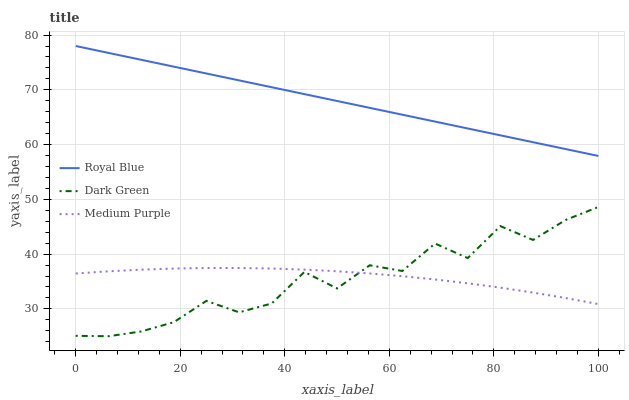Does Dark Green have the minimum area under the curve?
Answer yes or no. Yes. Does Royal Blue have the maximum area under the curve?
Answer yes or no. Yes. Does Royal Blue have the minimum area under the curve?
Answer yes or no. No. Does Dark Green have the maximum area under the curve?
Answer yes or no. No. Is Royal Blue the smoothest?
Answer yes or no. Yes. Is Dark Green the roughest?
Answer yes or no. Yes. Is Dark Green the smoothest?
Answer yes or no. No. Is Royal Blue the roughest?
Answer yes or no. No. Does Dark Green have the lowest value?
Answer yes or no. Yes. Does Royal Blue have the lowest value?
Answer yes or no. No. Does Royal Blue have the highest value?
Answer yes or no. Yes. Does Dark Green have the highest value?
Answer yes or no. No. Is Dark Green less than Royal Blue?
Answer yes or no. Yes. Is Royal Blue greater than Dark Green?
Answer yes or no. Yes. Does Dark Green intersect Medium Purple?
Answer yes or no. Yes. Is Dark Green less than Medium Purple?
Answer yes or no. No. Is Dark Green greater than Medium Purple?
Answer yes or no. No. Does Dark Green intersect Royal Blue?
Answer yes or no. No. 